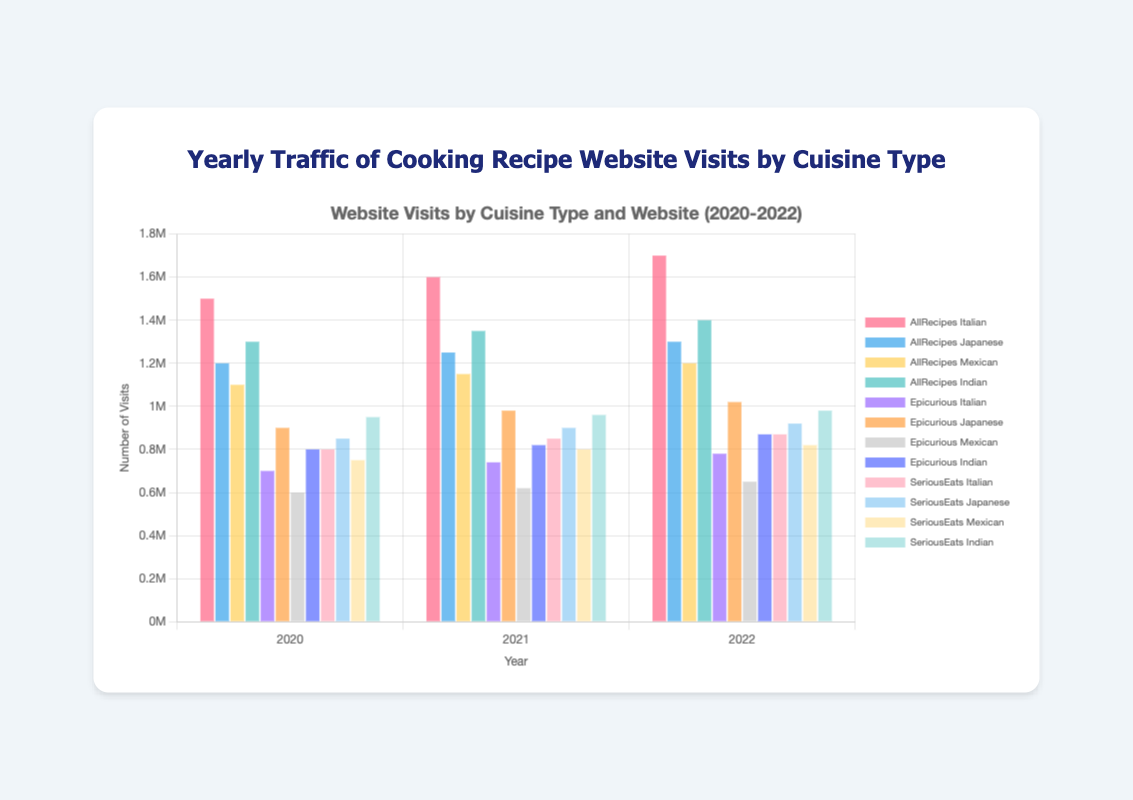Which website had the highest number of visits for Italian cuisine in 2021? To determine which website had the highest number of visits for Italian cuisine in 2021, look for the highest bar among 'AllRecipes Italian', 'Epicurious Italian', and 'SeriousEats Italian' for the year 2021. 'AllRecipes Italian' had 1,600,000 visits while 'Epicurious Italian' had 740,000 visits, and 'SeriousEats Italian' had 850,000 visits. Therefore, 'AllRecipes Italian' has the highest number of visits.
Answer: AllRecipes From 2020 to 2022, how did the visits to Epicurious for Japanese cuisine change? Observe the bars for 'Epicurious Japanese' for the years 2020, 2021, and 2022. In 2020, the visits were 900,000; in 2021, they increased to 980,000; and in 2022, they further increased to 1,020,000. Hence, there is a noticeable increase each year.
Answer: Increased In 2022, which website and cuisine type combination had the lowest number of visits? For 2022, identify the shortest bars across all website and cuisine combinations. The shortest bar is 'Epicurious Mexican' with 650,000 visits.
Answer: Epicurious Mexican What's the average number of visits across all websites for Indian cuisine in 2021? The visits for Indian cuisine in 2021 are 'AllRecipes Indian' (1,350,000), 'Epicurious Indian' (820,000), and 'SeriousEats Indian' (960,000). The average is calculated as (1,350,000 + 820,000 + 960,000) / 3 = 3,130,000 / 3 = 1,043,333.33.
Answer: 1,043,333.33 For which cuisine did AllRecipes see the least total number of visits over the three years? Calculate the sum of visits for each cuisine across the three years for AllRecipes: Italian (1,500,000 + 1,600,000 + 1,700,000 = 4,800,000), Japanese (1,200,000 + 1,250,000 + 1,300,000 = 3,750,000), Mexican (1,100,000 + 1,150,000 + 1,200,000 = 3,450,000), and Indian (1,300,000 + 1,350,000 + 1,400,000 = 4,050,000). Mexican has the least total visits.
Answer: Mexican Which website had a greater increase in visits for Mexican cuisine from 2020 to 2021, AllRecipes or SeriousEats? For 'AllRecipes Mexican', the increase is from 1,100,000 in 2020 to 1,150,000 in 2021, a difference of 50,000. For 'SeriousEats Mexican', the increase is from 750,000 in 2020 to 800,000 in 2021, a difference of 50,000. Both websites had an equal increase.
Answer: Both Compare the total number of visits for Italian cuisine across all websites in 2022. Which one had the highest? Sum the Italian visits for each website in 2022: 'AllRecipes Italian' (1,700,000), 'Epicurious Italian' (780,000), and 'SeriousEats Italian' (870,000). 'AllRecipes Italian' has the highest total.
Answer: AllRecipes 